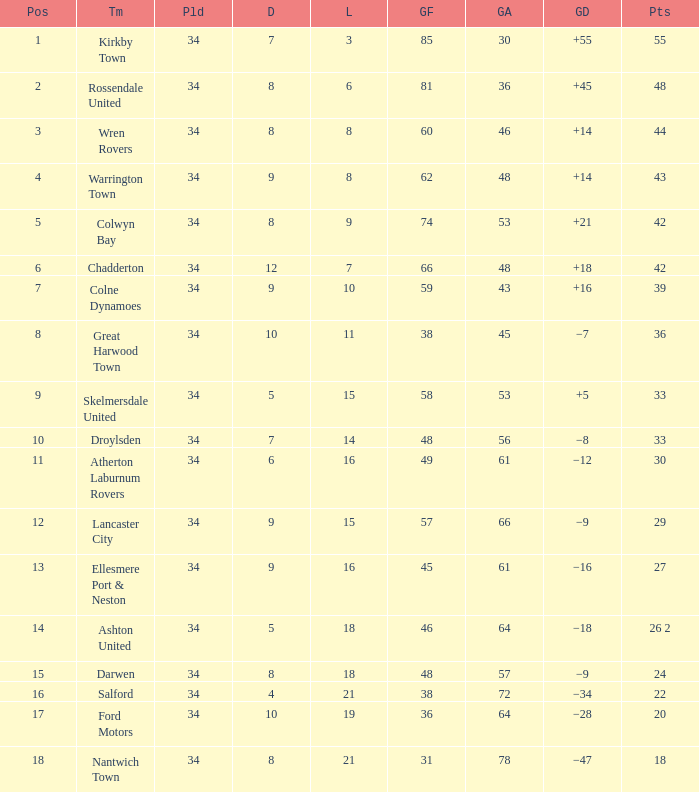What is the total number of positions when there are more than 48 goals against, 1 of 29 points are played, and less than 34 games have been played? 0.0. 